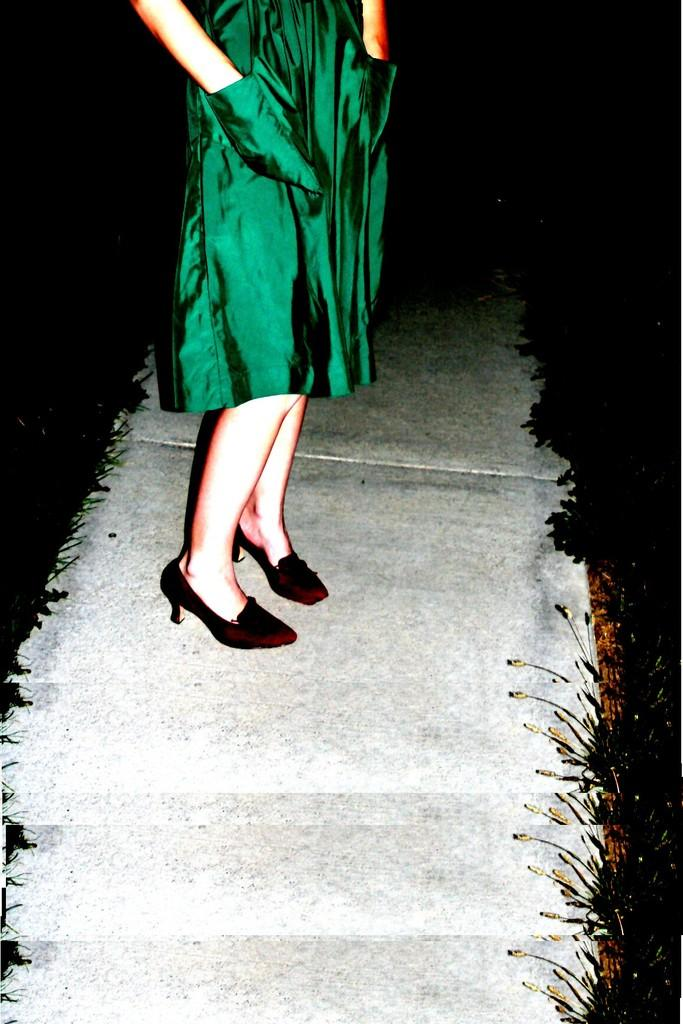Who or what is the main subject of the image? There is a person in the image. What is the person wearing? The person is wearing a green dress. What is the person standing on? The person is standing on a surface. What can be observed about the background of the image? The background of the image is dark. Is the person holding an umbrella in the image? There is no umbrella present in the image. What type of birthday celebration is taking place in the image? There is no birthday celebration depicted in the image. 